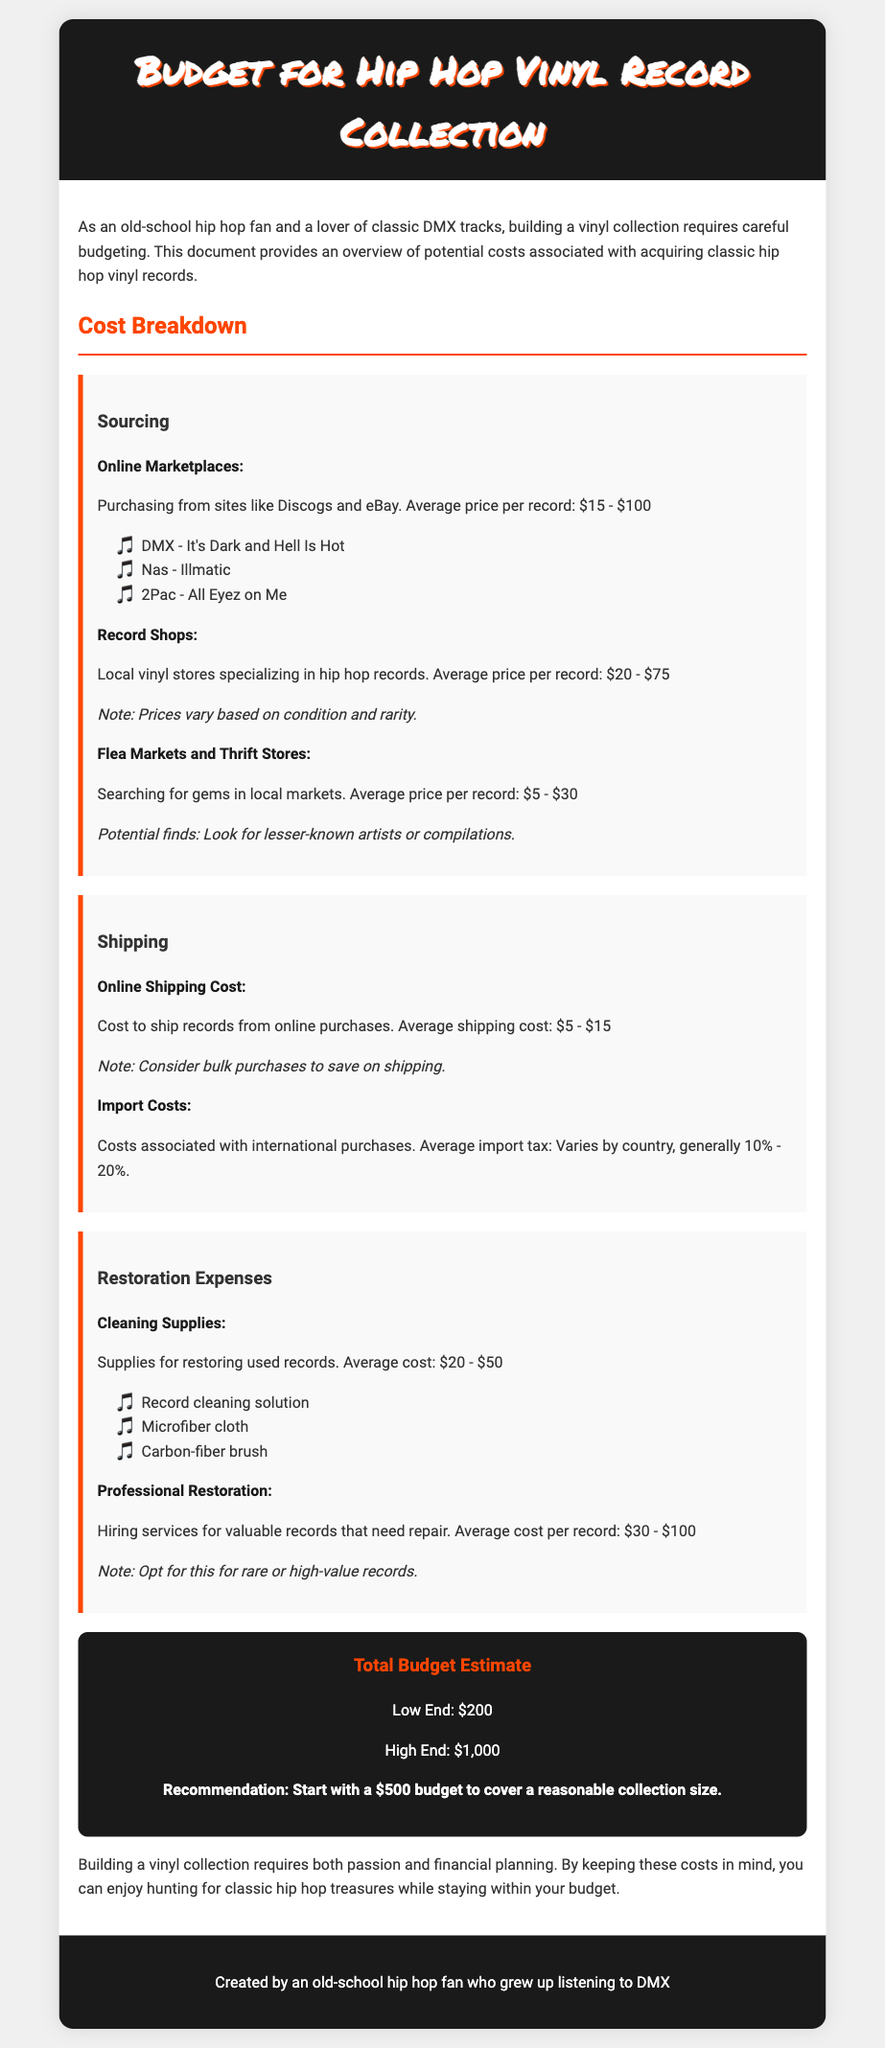What is the average price per record at online marketplaces? The document states that the average price per record from online marketplaces like Discogs and eBay is between $15 and $100.
Answer: $15 - $100 What is the lower-end total budget estimate? The document provides the total budget estimate, indicating the low end is $200.
Answer: $200 What supplies are mentioned for cleaning records? The document lists items such as record cleaning solution, microfiber cloth, and carbon-fiber brush.
Answer: Record cleaning solution, microfiber cloth, carbon-fiber brush What is the average shipping cost for online purchases? The document indicates that the average shipping cost for online purchases is between $5 to $15.
Answer: $5 - $15 What is the recommended budget to start a vinyl collection? According to the document, the recommendation for a starting budget is $500.
Answer: $500 What is the price range for professional restoration services? The document specifies that the average cost per record for professional restoration is between $30 and $100.
Answer: $30 - $100 What average price should one expect at local record shops? The document states that the average price per record at local record shops is between $20 and $75.
Answer: $20 - $75 What are the average import tax rates for international purchases? The document notes that the average import tax generally ranges from 10% to 20%.
Answer: 10% - 20% 